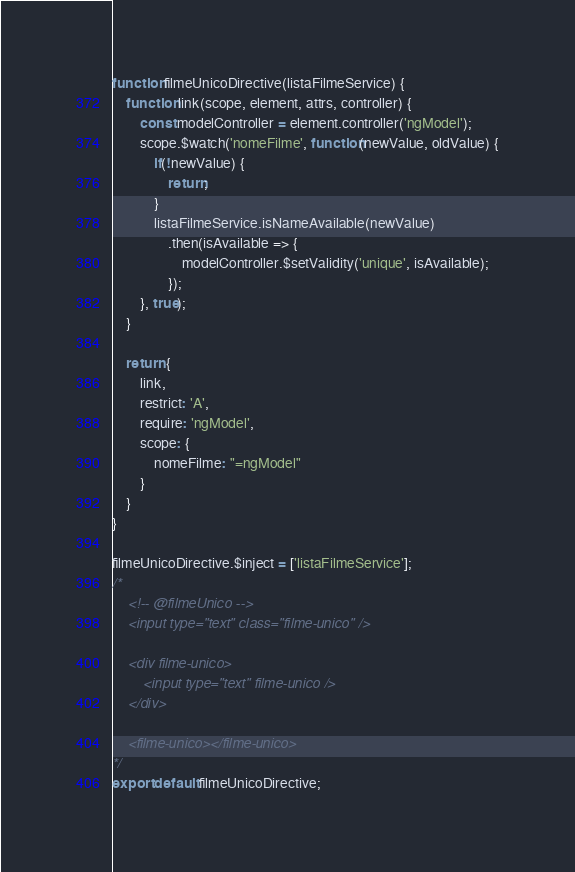<code> <loc_0><loc_0><loc_500><loc_500><_JavaScript_>
function filmeUnicoDirective(listaFilmeService) {
    function link(scope, element, attrs, controller) {
        const modelController = element.controller('ngModel');
        scope.$watch('nomeFilme', function(newValue, oldValue) {
            if(!newValue) {
                return;
            }
            listaFilmeService.isNameAvailable(newValue)
                .then(isAvailable => {
                    modelController.$setValidity('unique', isAvailable);
                });
        }, true);
    }

    return {
        link,
        restrict: 'A',
        require: 'ngModel',
        scope: {
            nomeFilme: "=ngModel"
        }
    }
}

filmeUnicoDirective.$inject = ['listaFilmeService'];
/*
    <!-- @filmeUnico -->
    <input type="text" class="filme-unico" />

    <div filme-unico>
        <input type="text" filme-unico />
    </div>

    <filme-unico></filme-unico>
*/
export default filmeUnicoDirective;</code> 